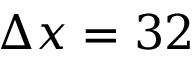Convert formula to latex. <formula><loc_0><loc_0><loc_500><loc_500>\Delta x = 3 2</formula> 